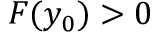Convert formula to latex. <formula><loc_0><loc_0><loc_500><loc_500>F ( y _ { 0 } ) > 0</formula> 